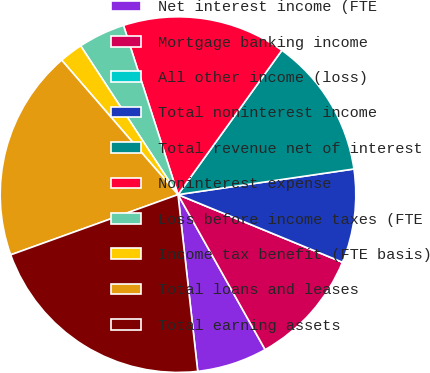Convert chart to OTSL. <chart><loc_0><loc_0><loc_500><loc_500><pie_chart><fcel>Net interest income (FTE<fcel>Mortgage banking income<fcel>All other income (loss)<fcel>Total noninterest income<fcel>Total revenue net of interest<fcel>Noninterest expense<fcel>Loss before income taxes (FTE<fcel>Income tax benefit (FTE basis)<fcel>Total loans and leases<fcel>Total earning assets<nl><fcel>6.38%<fcel>10.64%<fcel>0.0%<fcel>8.51%<fcel>12.77%<fcel>14.89%<fcel>4.26%<fcel>2.13%<fcel>19.15%<fcel>21.27%<nl></chart> 